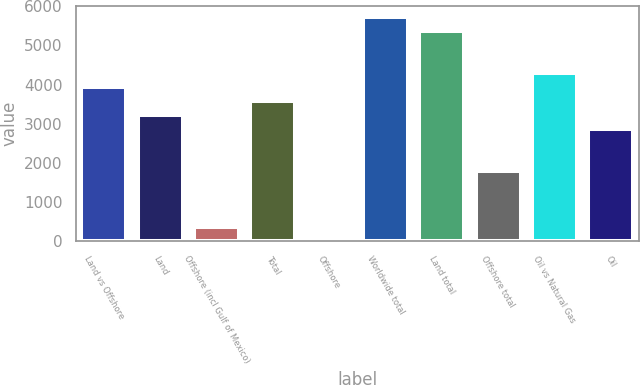<chart> <loc_0><loc_0><loc_500><loc_500><bar_chart><fcel>Land vs Offshore<fcel>Land<fcel>Offshore (incl Gulf of Mexico)<fcel>Total<fcel>Offshore<fcel>Worldwide total<fcel>Land total<fcel>Offshore total<fcel>Oil vs Natural Gas<fcel>Oil<nl><fcel>3935.6<fcel>3220.4<fcel>359.6<fcel>3578<fcel>2<fcel>5723.6<fcel>5366<fcel>1790<fcel>4293.2<fcel>2862.8<nl></chart> 